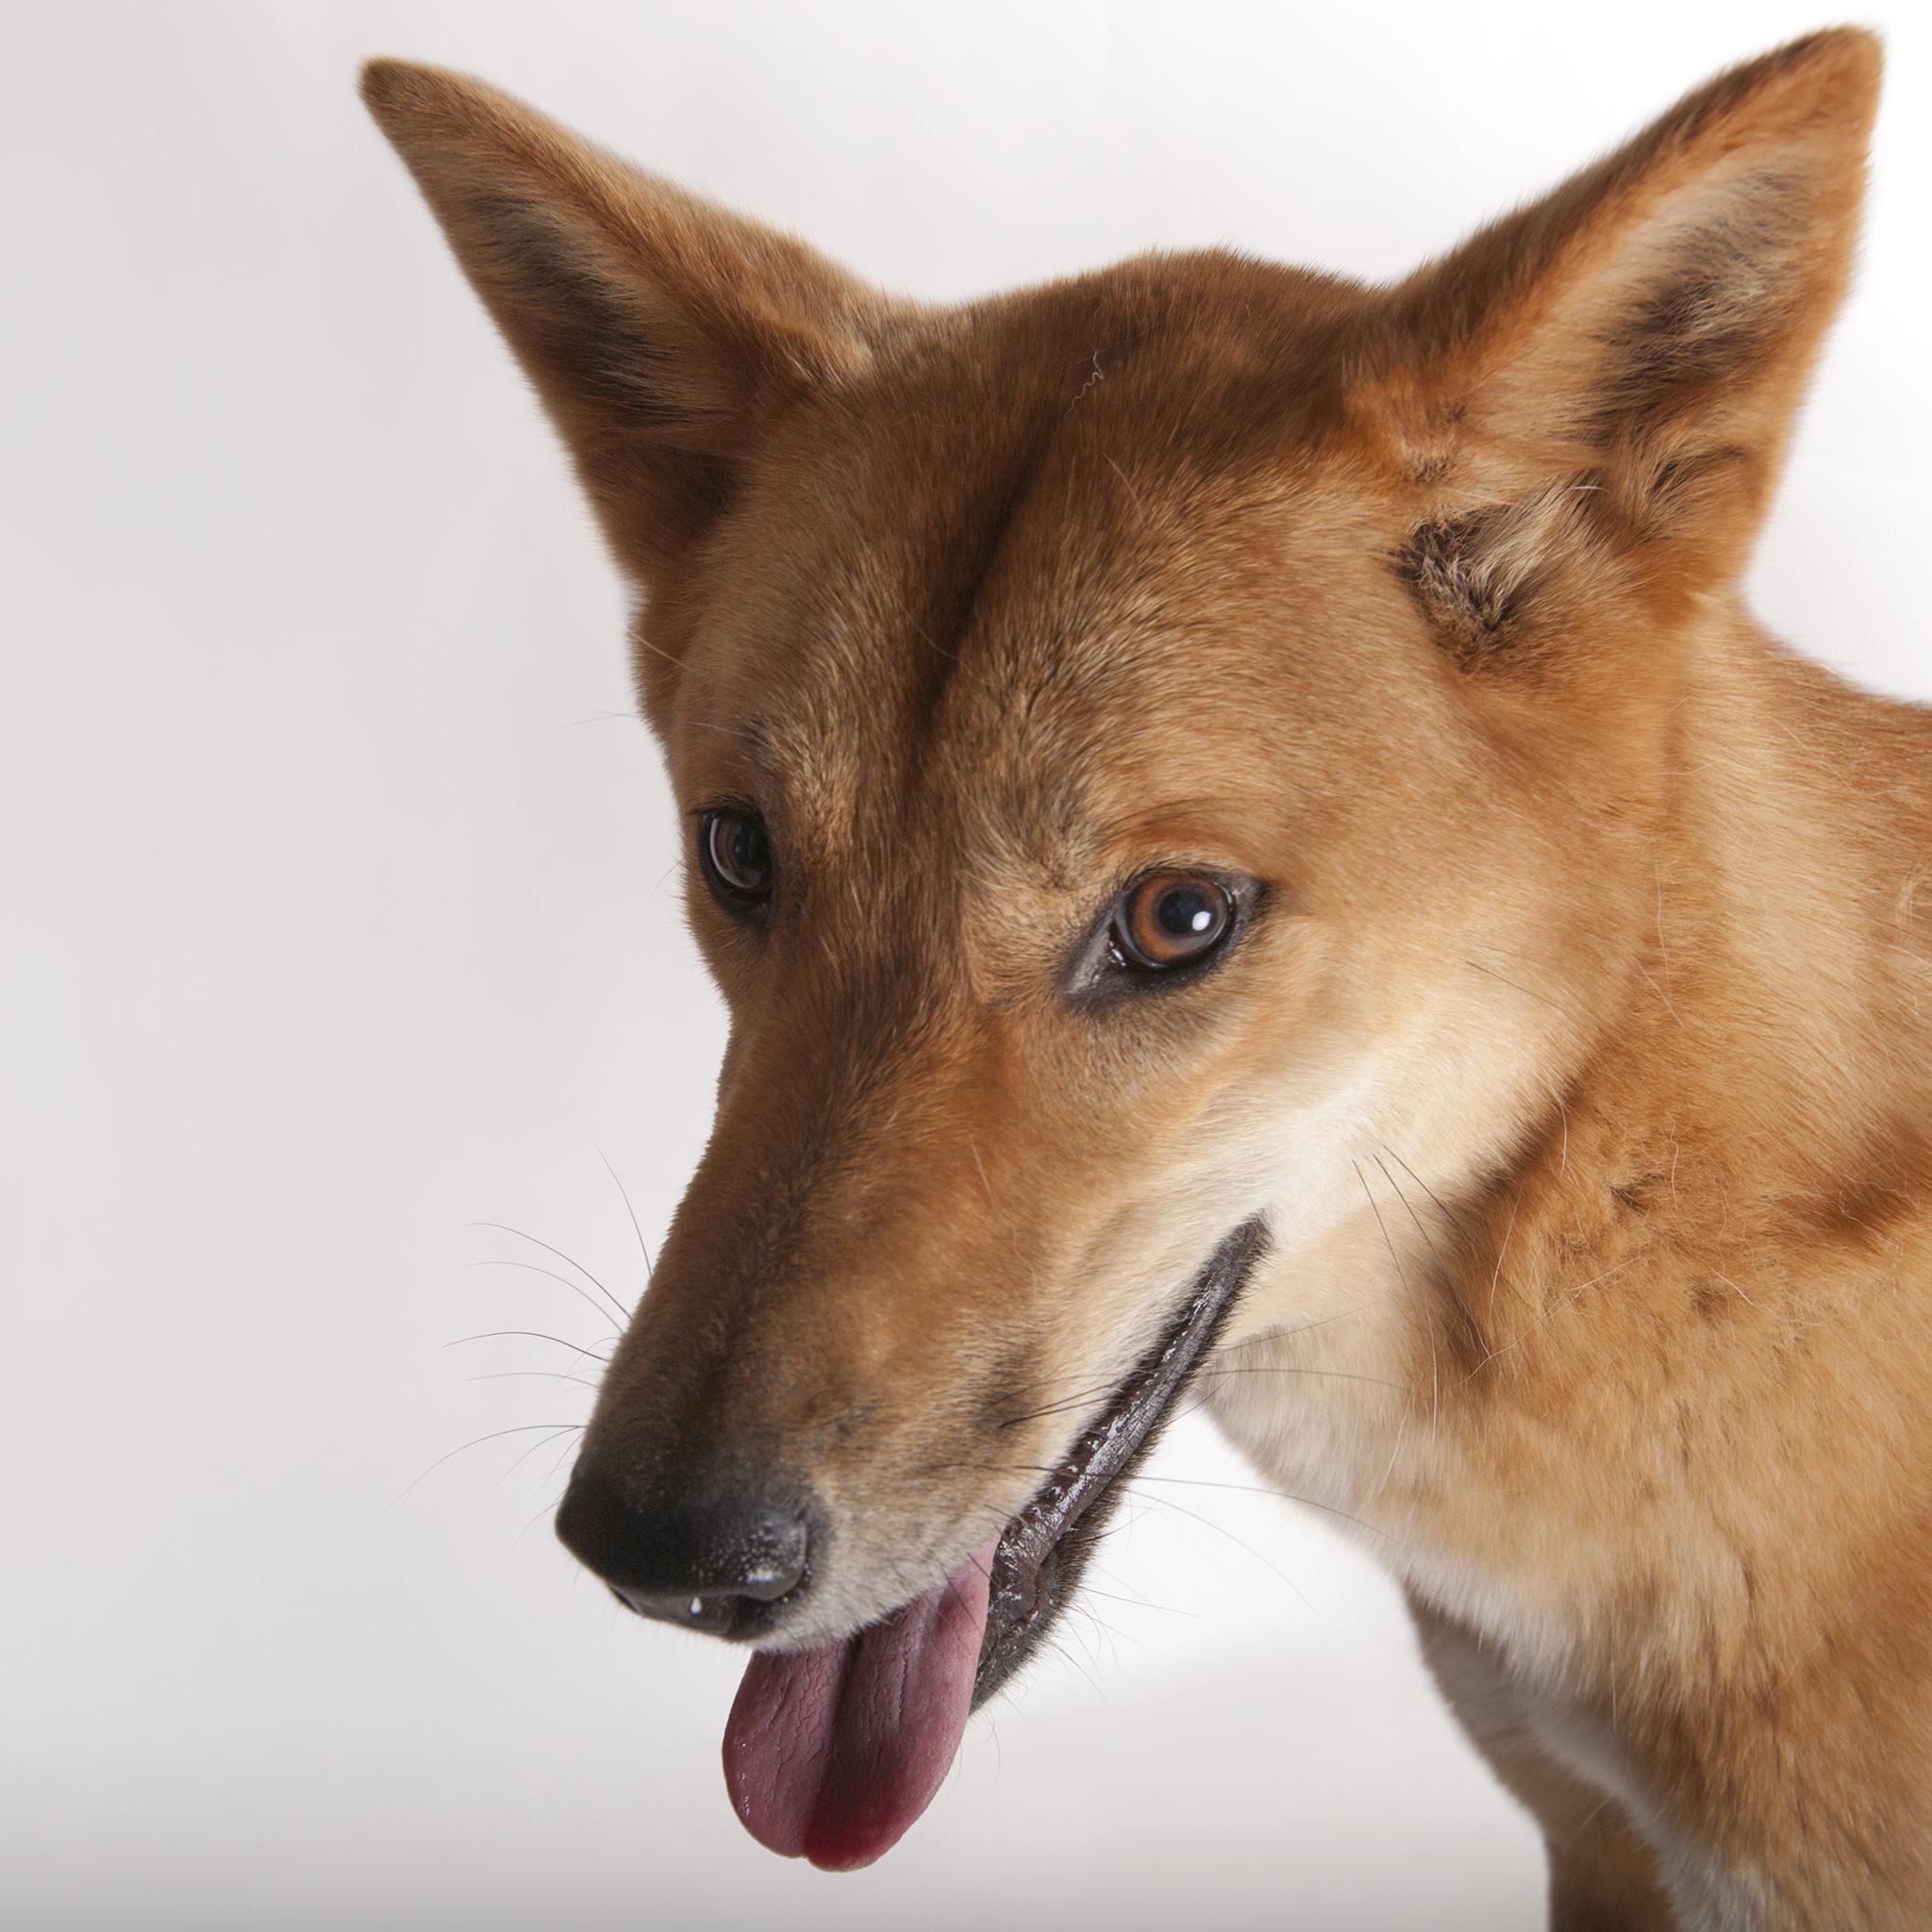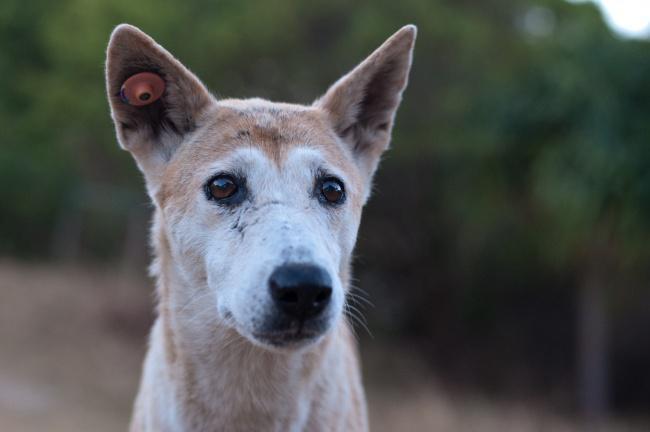The first image is the image on the left, the second image is the image on the right. Considering the images on both sides, is "The left image shows a dog gazing leftward, and the right image shows a dog whose gaze is more forward." valid? Answer yes or no. Yes. 